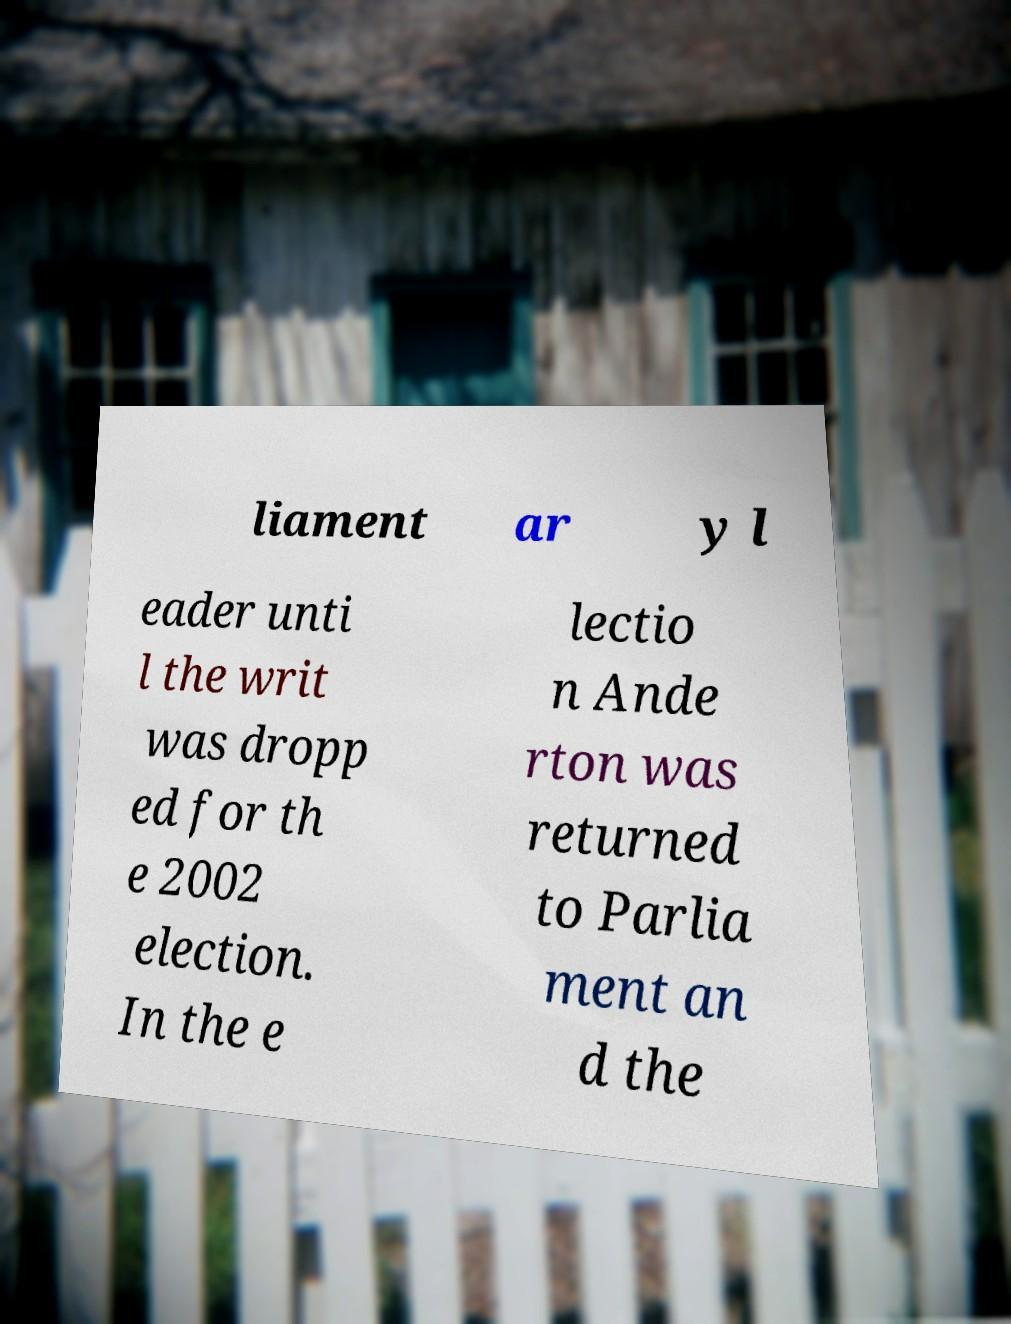There's text embedded in this image that I need extracted. Can you transcribe it verbatim? liament ar y l eader unti l the writ was dropp ed for th e 2002 election. In the e lectio n Ande rton was returned to Parlia ment an d the 